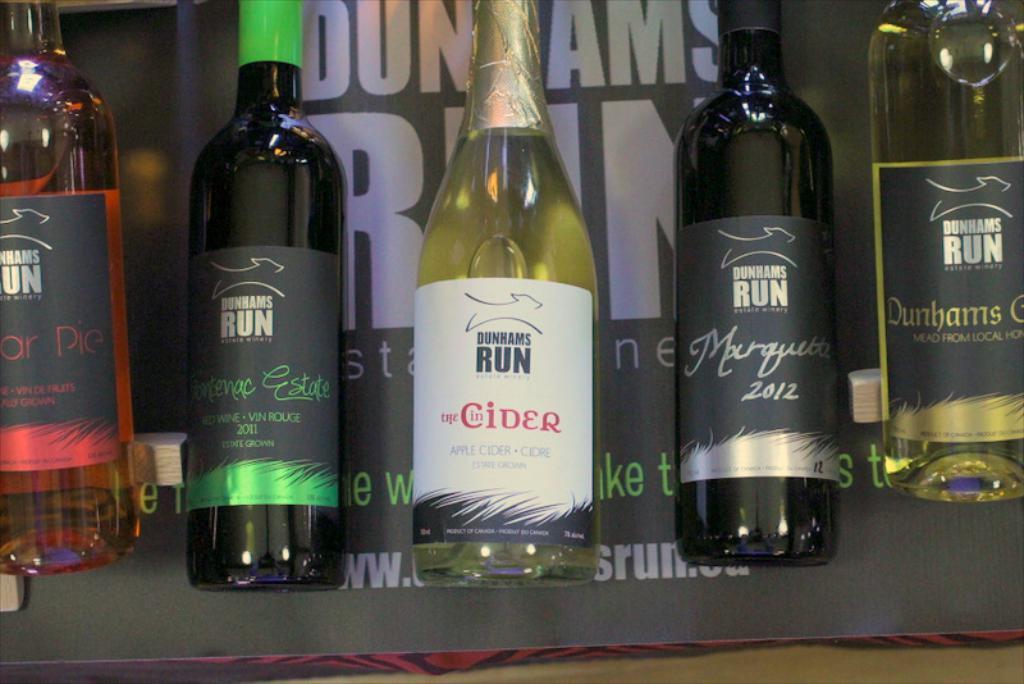Please provide a concise description of this image. There are five bottles in the image. In the background there is a board. 